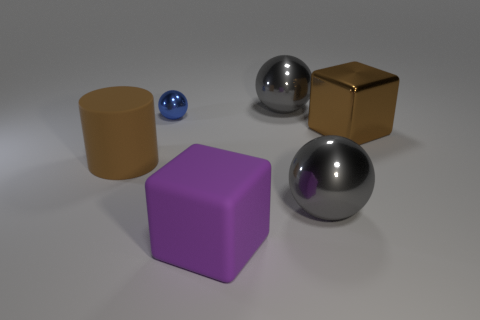How many other objects are the same size as the blue metallic thing?
Offer a terse response. 0. What size is the rubber cylinder?
Keep it short and to the point. Large. Do the large cylinder and the big object behind the small blue metal object have the same material?
Keep it short and to the point. No. Are there any other tiny brown metallic things of the same shape as the tiny object?
Ensure brevity in your answer.  No. What material is the cylinder that is the same size as the shiny block?
Keep it short and to the point. Rubber. There is a brown thing that is on the right side of the large purple rubber cube; what is its size?
Offer a very short reply. Large. Is the size of the rubber object that is to the right of the tiny blue ball the same as the block that is behind the matte cube?
Keep it short and to the point. Yes. What number of big brown things are the same material as the blue ball?
Provide a succinct answer. 1. What color is the big rubber cube?
Provide a short and direct response. Purple. Are there any big gray objects left of the blue metal sphere?
Keep it short and to the point. No. 